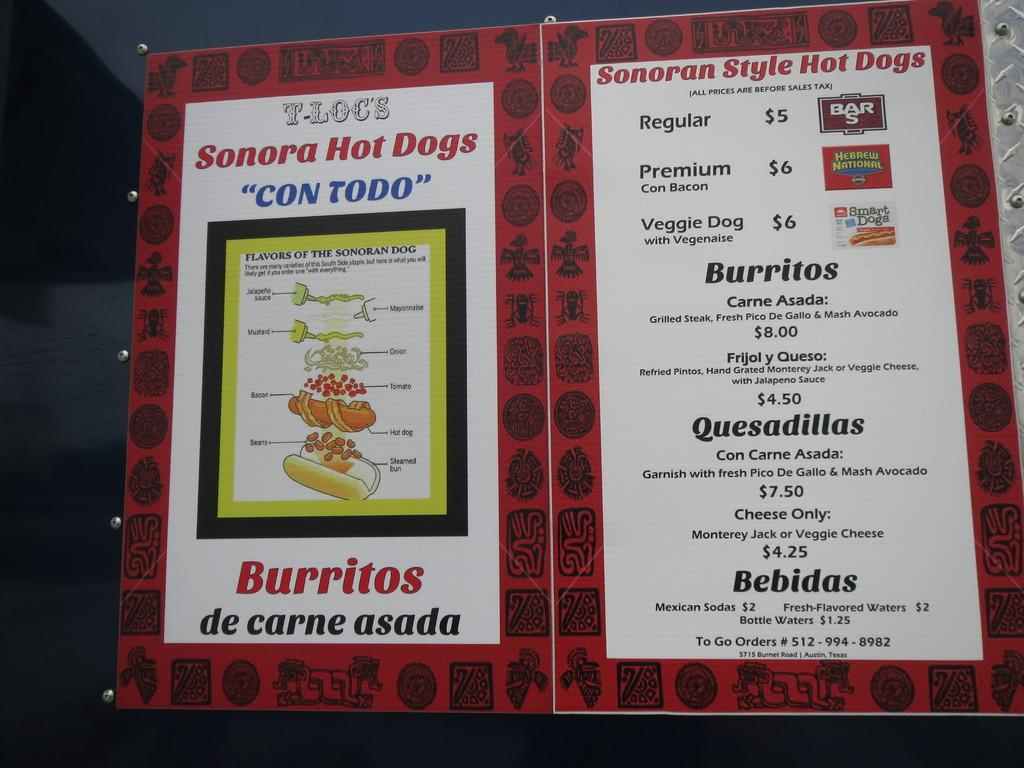<image>
Relay a brief, clear account of the picture shown. A menu for a restaurant that sells hot dogs and burritos. 